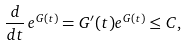Convert formula to latex. <formula><loc_0><loc_0><loc_500><loc_500>\frac { d } { d t } \, e ^ { G ( t ) } = G ^ { \prime } ( t ) e ^ { G ( t ) } \leq C ,</formula> 